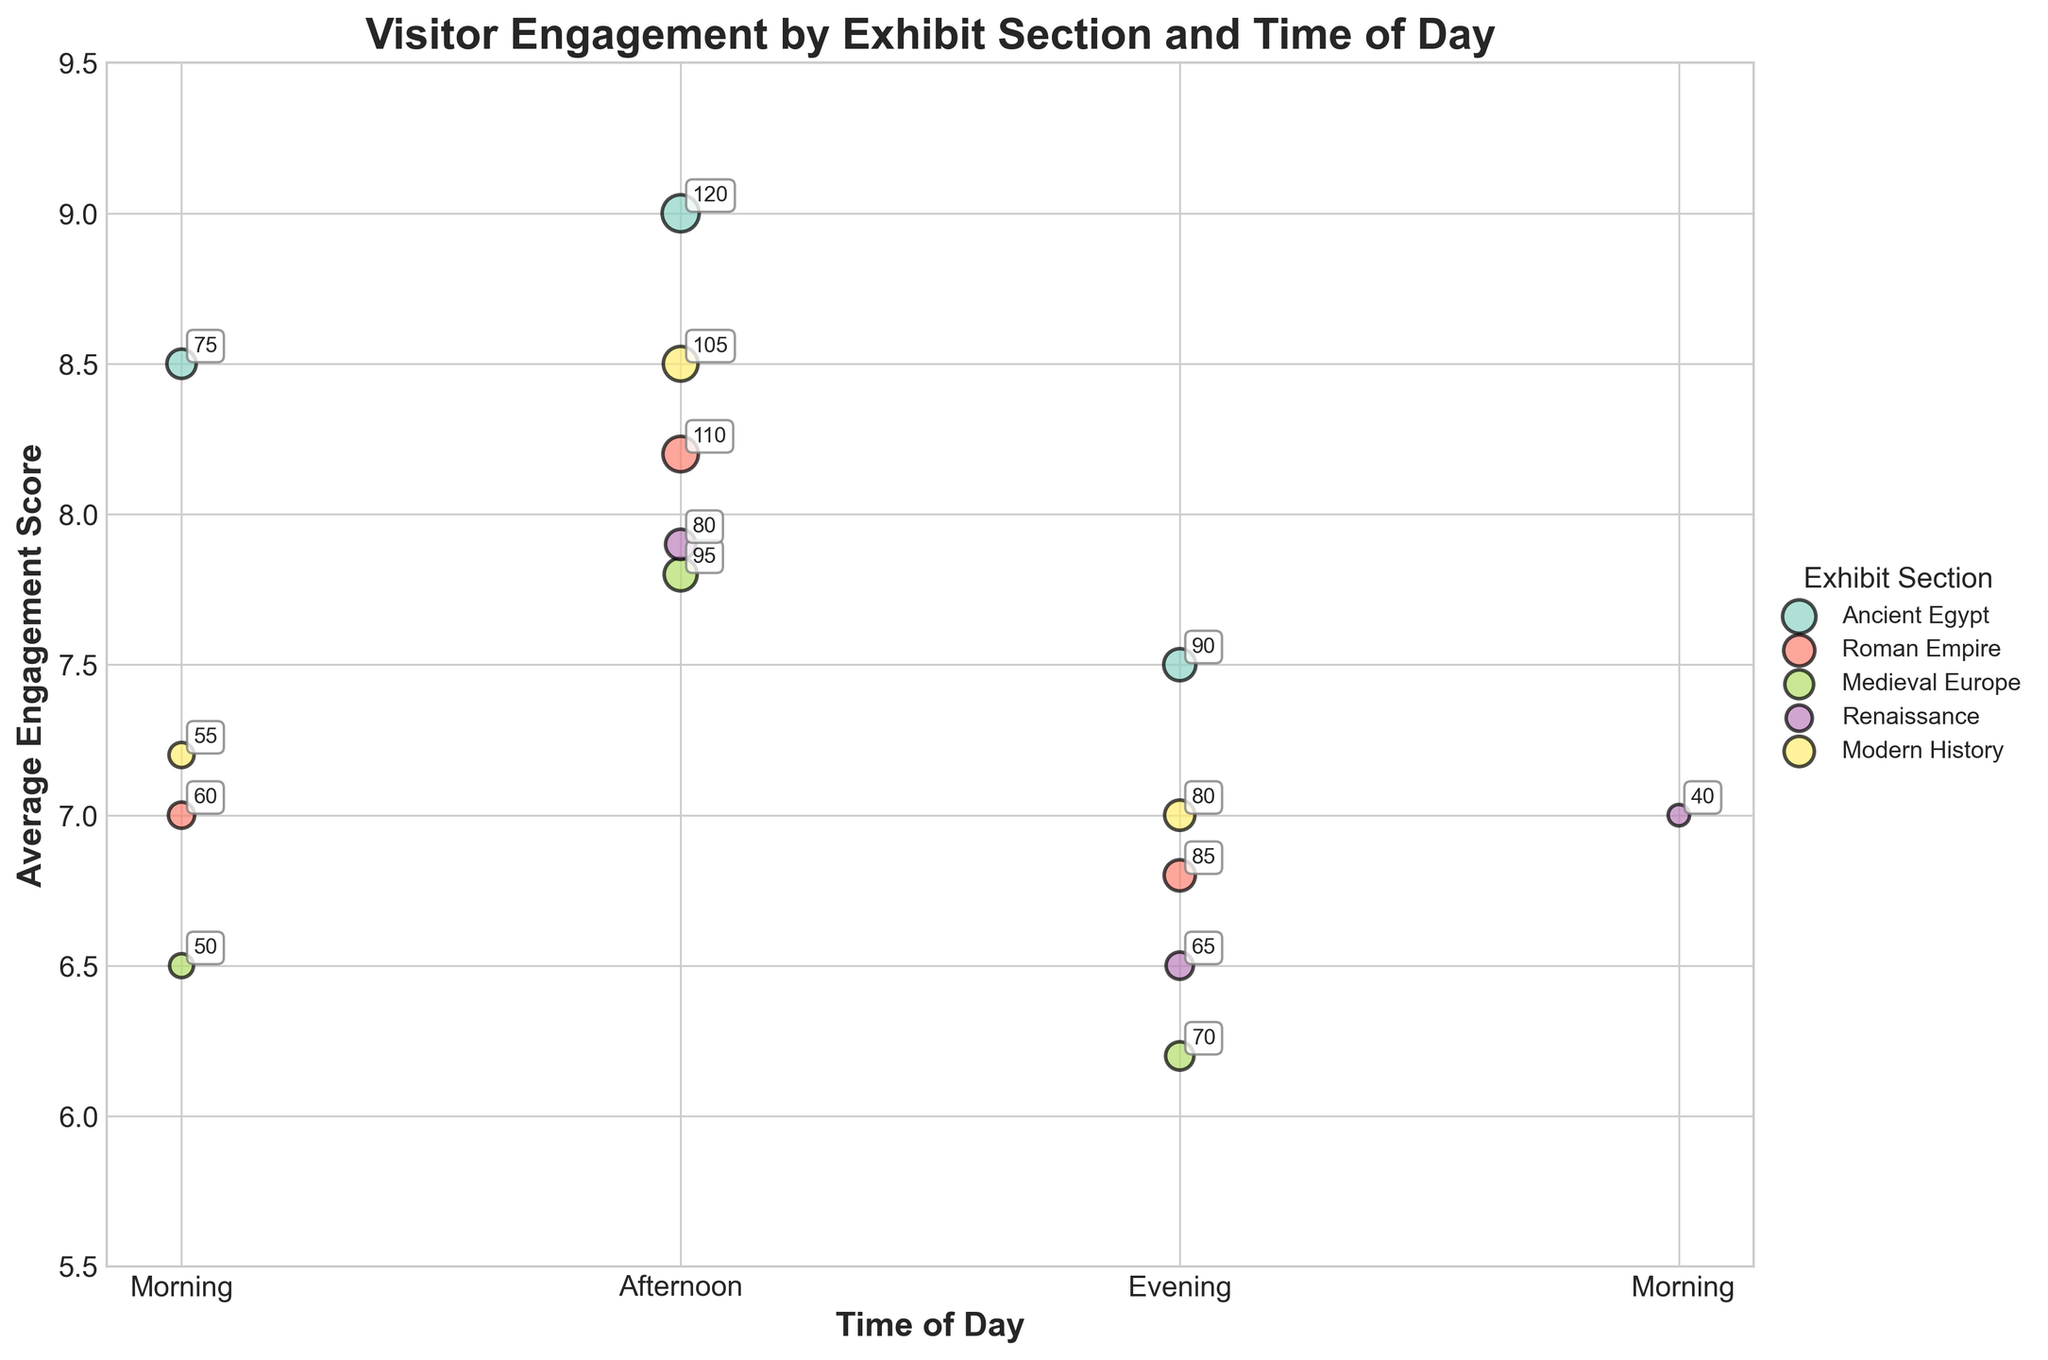What is the title of the plot? The title of the plot is indicated at the top in a larger, bold font. It reads "Visitor Engagement by Exhibit Section and Time of Day".
Answer: Visitor Engagement by Exhibit Section and Time of Day Which exhibit section has the highest average engagement score in the morning? In the morning, look for the highest y-axis value. Ancient Egypt reaches 8.5, which is the highest for the morning.
Answer: Ancient Egypt What is the total number of visitors in the afternoon for Ancient Egypt and Modern History? Sum the number of visitors for Ancient Egypt (120) and Modern History (105) in the afternoon. 120 + 105 = 225.
Answer: 225 Which exhibit section experiences the highest number of visitors in the evening? In the evening, the bubble for Ancient Egypt is the largest, indicating it has the highest number of visitors, which is 90.
Answer: Ancient Egypt How does the engagement score of the Roman Empire in the afternoon compare to the evening? Check the y-axis positions for Roman Empire in the afternoon (8.2) and evening (6.8). The afternoon has a higher engagement score.
Answer: Afternoon score is higher What are the time periods with the lowest engagement scores for each exhibit section? Identify the smallest y-value for each section: 
- Ancient Egypt: Evening (7.5)
- Roman Empire: Evening (6.8)
- Medieval Europe: Evening (6.2)
- Renaissance: Evening (6.5)
- Modern History: Evening (7.0)
Answer: All sections' lowest engagement scores are in the evening Which two exhibit sections have the closest average engagement scores in the morning? Compare morning engagement scores: 
- Ancient Egypt: 8.5
- Roman Empire: 7.0
- Medieval Europe: 6.5
- Renaissance: 7.0
- Modern History: 7.2
Roman Empire and Renaissance both have 7.0.
Answer: Roman Empire and Renaissance During which time of day does Modern History have the highest average engagement score? Modern History has the highest y-value between morning (7.2), afternoon (8.5), and evening (7.0). The highest score is in the afternoon.
Answer: Afternoon What is the average engagement score of all sections in the afternoon? Calculate the average score for the afternoon:
(9.0 + 8.2 + 7.8 + 7.9 + 8.5) / 5 
= 41.4 / 5 
= 8.28
Answer: 8.28 Which exhibit section has the least variation in average engagement score across the day? Compare the ranges (max - min) of engagement scores:
- Ancient Egypt: 9.0 - 7.5 = 1.5
- Roman Empire: 8.2 - 6.8 = 1.4
- Medieval Europe: 7.8 - 6.2 = 1.6
- Renaissance: 7.9 - 6.5 = 1.4
- Modern History: 8.5 - 7.0 = 1.5
Roman Empire and Renaissance both have a variation of 1.4, the smallest amount.
Answer: Roman Empire and Renaissance 